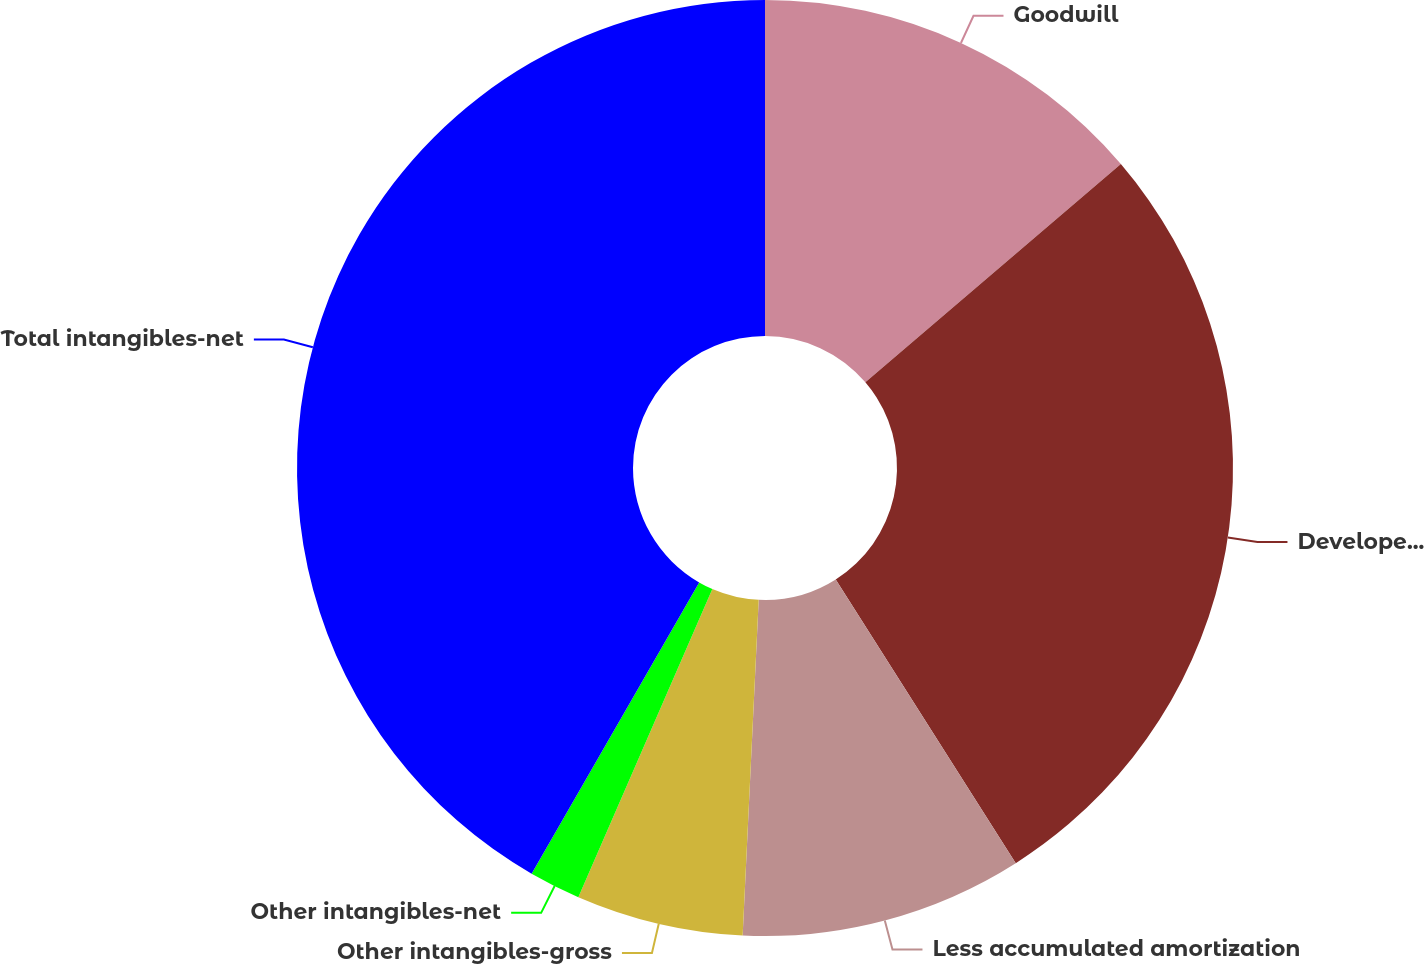<chart> <loc_0><loc_0><loc_500><loc_500><pie_chart><fcel>Goodwill<fcel>Developed product<fcel>Less accumulated amortization<fcel>Other intangibles-gross<fcel>Other intangibles-net<fcel>Total intangibles-net<nl><fcel>13.75%<fcel>27.25%<fcel>9.76%<fcel>5.77%<fcel>1.78%<fcel>41.69%<nl></chart> 